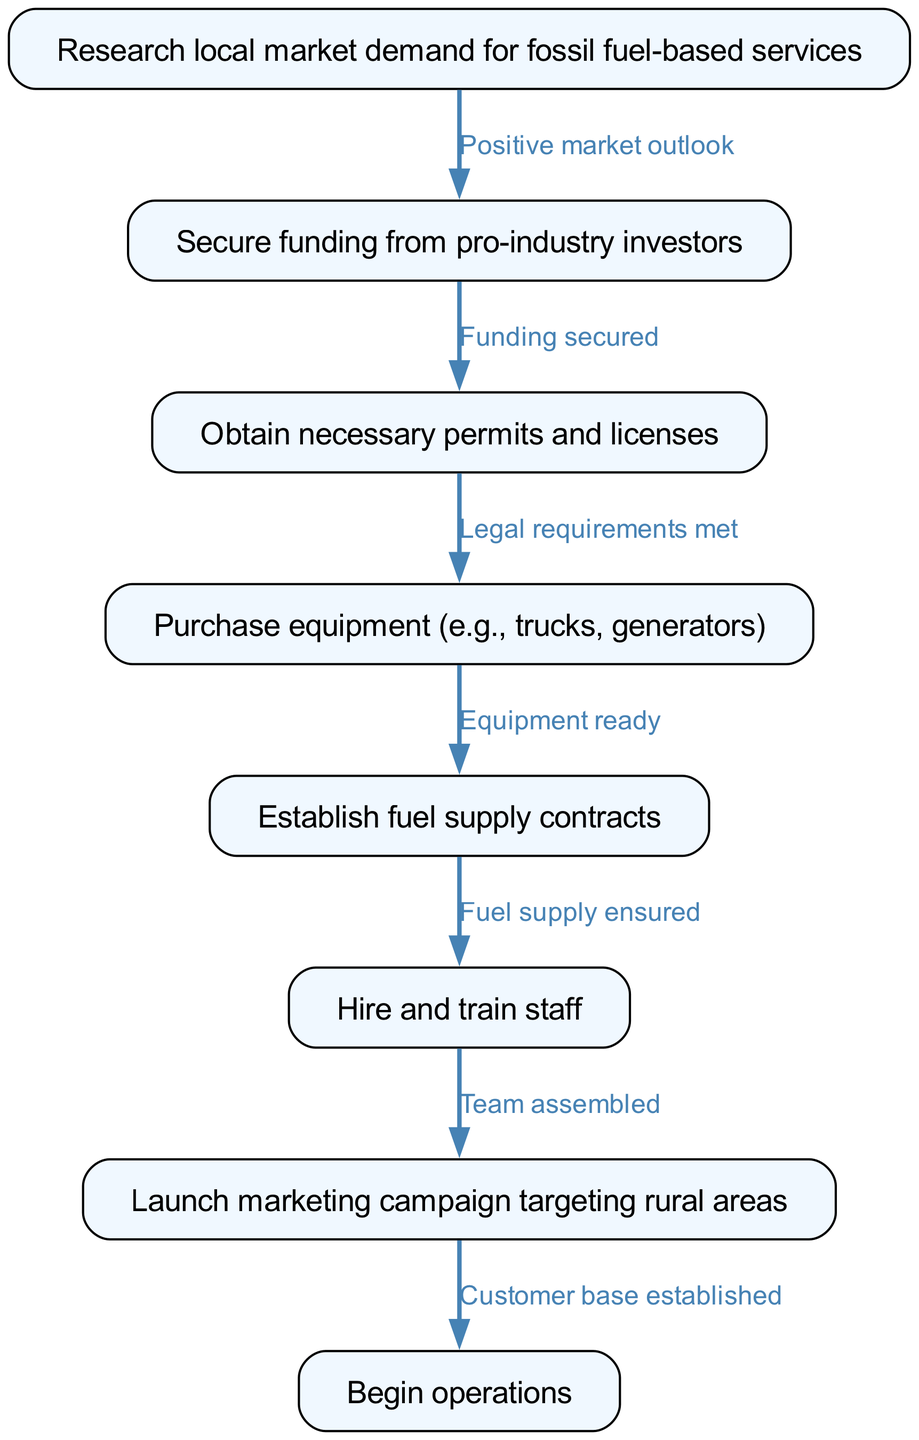What is the first step in the flow chart? The first node in the flow chart is labeled "Research local market demand for fossil fuel-based services," indicating that this is the initial step required before others can follow.
Answer: Research local market demand for fossil fuel-based services How many nodes are in the diagram? To find the total number of nodes, we count each unique item in the "nodes" section of the diagram data, which totals eight separate nodes that each represent a distinct step in the process.
Answer: Eight What relationship is indicated between nodes one and two? The edge connecting node one ("Research local market demand for fossil fuel-based services") to node two ("Secure funding from pro-industry investors") is labeled "Positive market outlook," showing that the first step positively influences the second step.
Answer: Positive market outlook What step follows after "Obtain necessary permits and licenses"? The node following "Obtain necessary permits and licenses," which is node three, leads to node four, labeled "Purchase equipment (e.g., trucks, generators)," indicating that licensing must precede equipment purchase.
Answer: Purchase equipment (e.g., trucks, generators) Which step emphasizes marketing? The node labeled "Launch marketing campaign targeting rural areas" is the focus on marketing efforts within the flow chart, showing that marketing is a distinct step in the overall process of starting the business.
Answer: Launch marketing campaign targeting rural areas What is the last step in the flow chart? The final node, labeled "Begin operations," indicates that this is the ultimate step in the flow chart after completing all previous steps, thereby marking the official start of the business activities.
Answer: Begin operations Which step requires securing funding? The node "Secure funding from pro-industry investors" requires funding to be obtained, as it directly follows a positive market outlook and precedes permit acquisition, which is crucial for progressing further.
Answer: Secure funding from pro-industry investors How many edges connect the nodes in the diagram? To determine the number of edges, we refer to the "edges" section and count them, where each edge represents a relationship between two steps, thus offering a total of seven connections.
Answer: Seven 